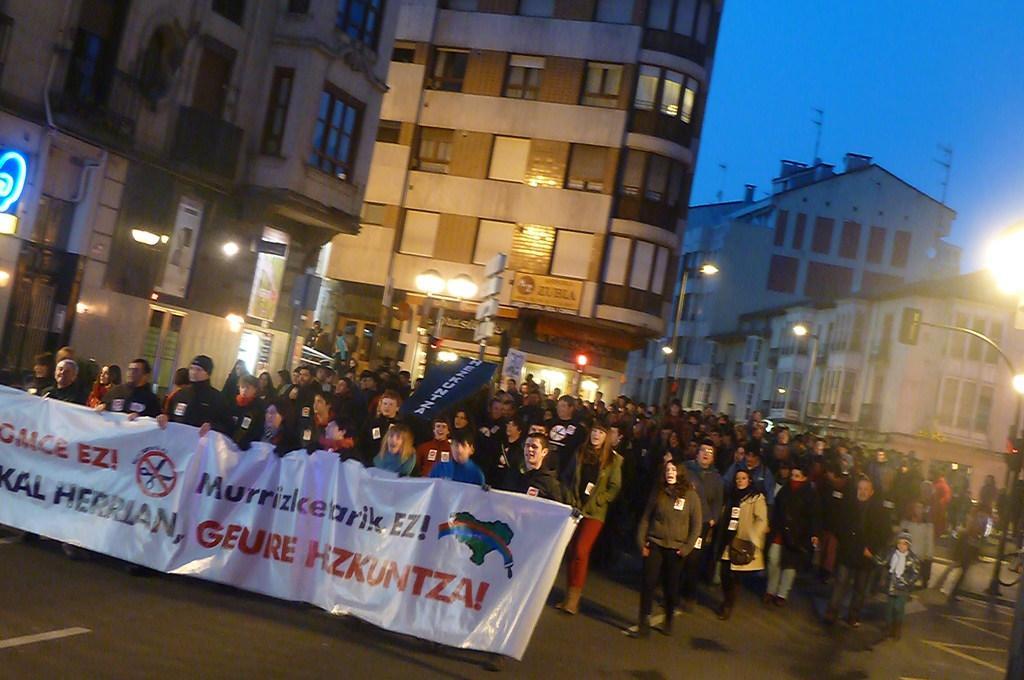Can you describe this image briefly? This is clicked in the street, In the front there are many walking on the road holding a banner in the front, in the back there are buildings all over the place and above its sky. 